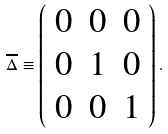Convert formula to latex. <formula><loc_0><loc_0><loc_500><loc_500>\overline { \Delta } \equiv \left ( \begin{array} { c c c } 0 & 0 & 0 \\ 0 & 1 & 0 \\ 0 & 0 & 1 \end{array} \right ) .</formula> 